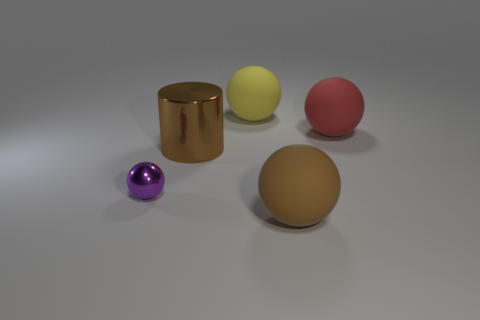Subtract all shiny spheres. How many spheres are left? 3 Add 2 big metal things. How many objects exist? 7 Subtract all spheres. How many objects are left? 1 Subtract all purple balls. How many balls are left? 3 Subtract 0 blue spheres. How many objects are left? 5 Subtract 2 spheres. How many spheres are left? 2 Subtract all yellow spheres. Subtract all green blocks. How many spheres are left? 3 Subtract all small purple things. Subtract all large brown things. How many objects are left? 2 Add 5 big brown things. How many big brown things are left? 7 Add 4 small purple metal objects. How many small purple metal objects exist? 5 